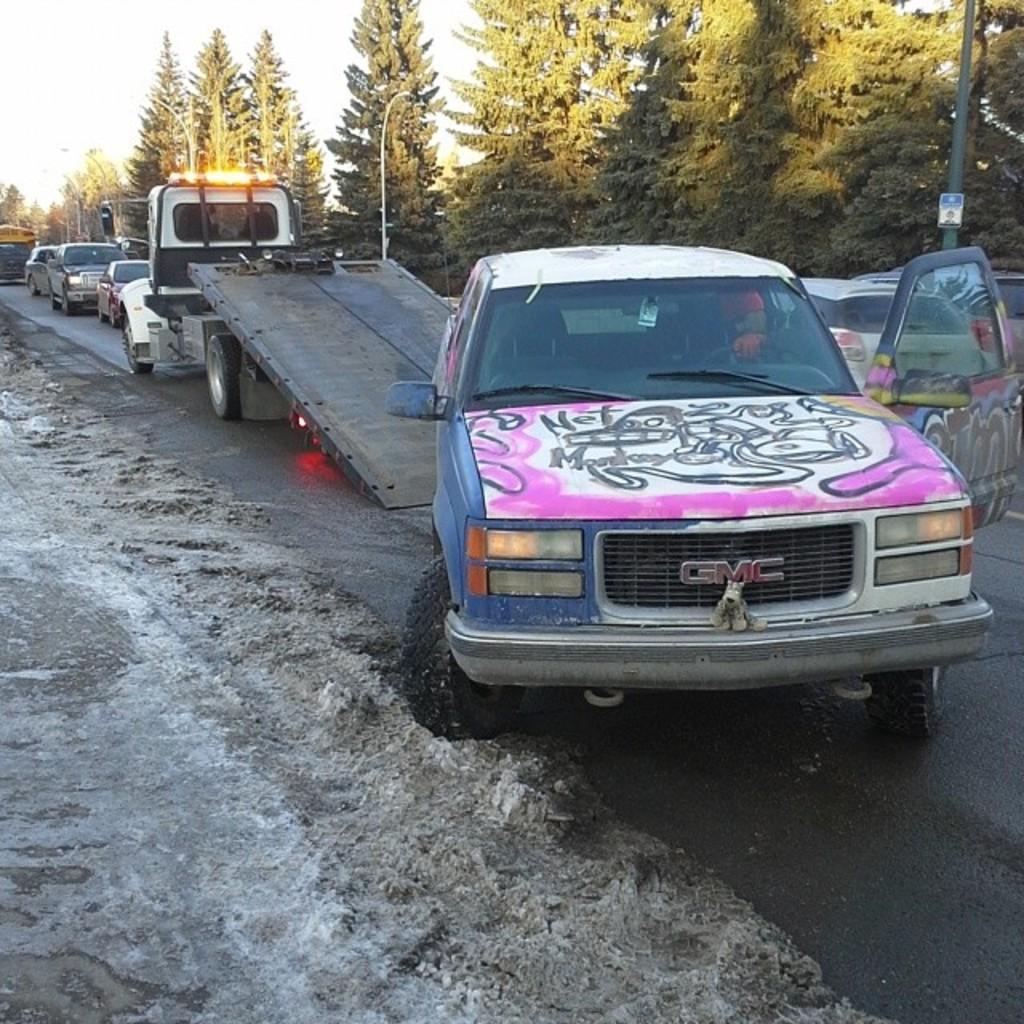Can you describe this image briefly? In this picture we can see a car being towed onto a truck. There are many other vehicles on the road surrounded by trees. 